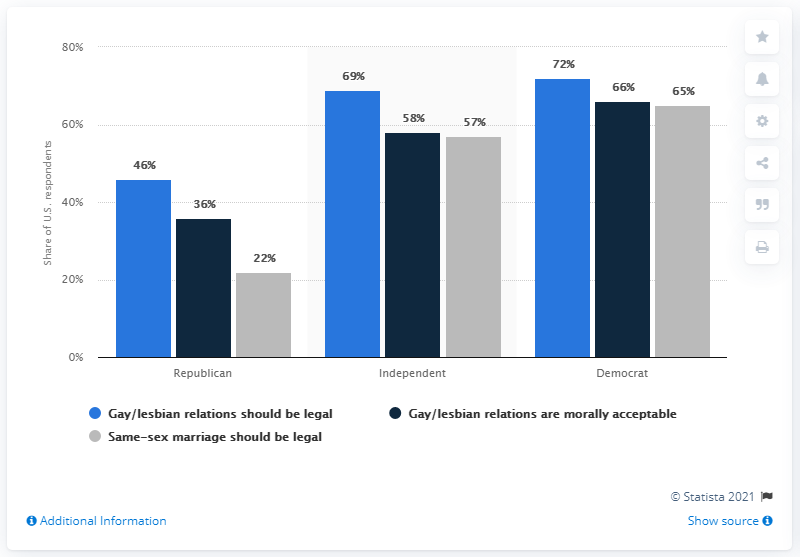Give some essential details in this illustration. The average percentage in the independent category is 61.33%. The blue bar in the Democrat category represents 72% of the total percentage value. 